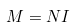<formula> <loc_0><loc_0><loc_500><loc_500>M = N I</formula> 